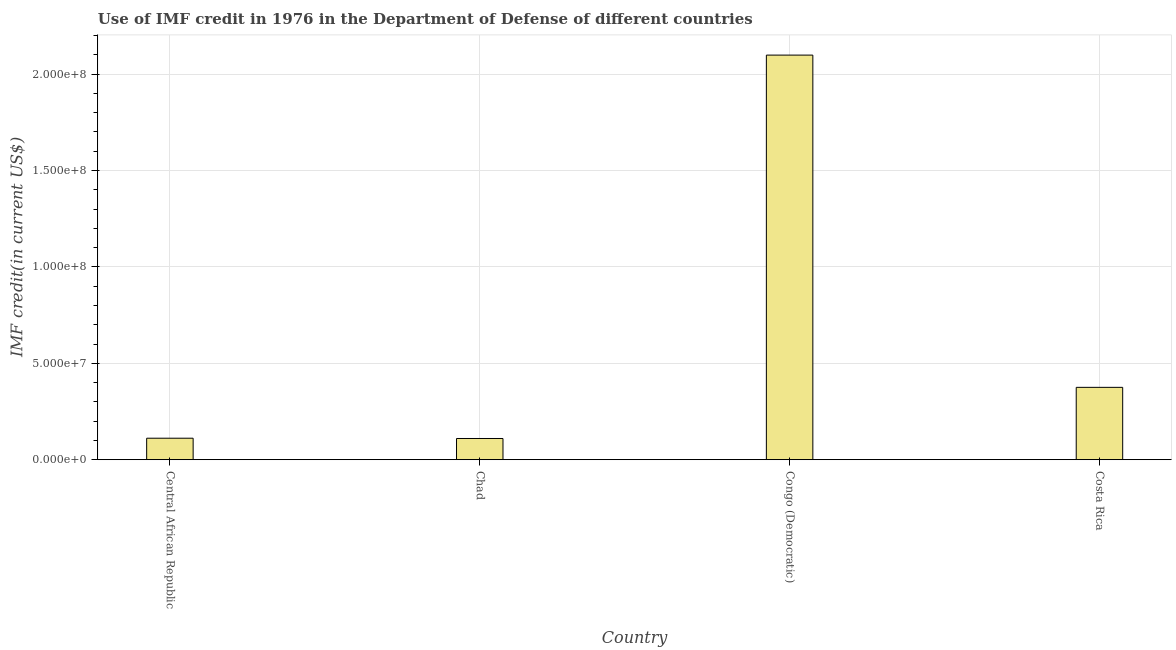Does the graph contain any zero values?
Offer a terse response. No. What is the title of the graph?
Your answer should be compact. Use of IMF credit in 1976 in the Department of Defense of different countries. What is the label or title of the Y-axis?
Offer a terse response. IMF credit(in current US$). What is the use of imf credit in dod in Central African Republic?
Make the answer very short. 1.11e+07. Across all countries, what is the maximum use of imf credit in dod?
Your response must be concise. 2.10e+08. Across all countries, what is the minimum use of imf credit in dod?
Offer a very short reply. 1.10e+07. In which country was the use of imf credit in dod maximum?
Offer a terse response. Congo (Democratic). In which country was the use of imf credit in dod minimum?
Provide a succinct answer. Chad. What is the sum of the use of imf credit in dod?
Offer a terse response. 2.70e+08. What is the difference between the use of imf credit in dod in Central African Republic and Congo (Democratic)?
Provide a succinct answer. -1.99e+08. What is the average use of imf credit in dod per country?
Give a very brief answer. 6.74e+07. What is the median use of imf credit in dod?
Your response must be concise. 2.43e+07. In how many countries, is the use of imf credit in dod greater than 50000000 US$?
Your answer should be very brief. 1. What is the ratio of the use of imf credit in dod in Central African Republic to that in Congo (Democratic)?
Offer a very short reply. 0.05. Is the use of imf credit in dod in Central African Republic less than that in Chad?
Provide a short and direct response. No. Is the difference between the use of imf credit in dod in Chad and Costa Rica greater than the difference between any two countries?
Make the answer very short. No. What is the difference between the highest and the second highest use of imf credit in dod?
Give a very brief answer. 1.72e+08. What is the difference between the highest and the lowest use of imf credit in dod?
Offer a very short reply. 1.99e+08. In how many countries, is the use of imf credit in dod greater than the average use of imf credit in dod taken over all countries?
Keep it short and to the point. 1. How many bars are there?
Keep it short and to the point. 4. How many countries are there in the graph?
Provide a succinct answer. 4. Are the values on the major ticks of Y-axis written in scientific E-notation?
Provide a short and direct response. Yes. What is the IMF credit(in current US$) in Central African Republic?
Give a very brief answer. 1.11e+07. What is the IMF credit(in current US$) of Chad?
Make the answer very short. 1.10e+07. What is the IMF credit(in current US$) of Congo (Democratic)?
Provide a succinct answer. 2.10e+08. What is the IMF credit(in current US$) of Costa Rica?
Offer a very short reply. 3.75e+07. What is the difference between the IMF credit(in current US$) in Central African Republic and Chad?
Give a very brief answer. 1.39e+05. What is the difference between the IMF credit(in current US$) in Central African Republic and Congo (Democratic)?
Your answer should be compact. -1.99e+08. What is the difference between the IMF credit(in current US$) in Central African Republic and Costa Rica?
Your answer should be very brief. -2.64e+07. What is the difference between the IMF credit(in current US$) in Chad and Congo (Democratic)?
Provide a succinct answer. -1.99e+08. What is the difference between the IMF credit(in current US$) in Chad and Costa Rica?
Keep it short and to the point. -2.65e+07. What is the difference between the IMF credit(in current US$) in Congo (Democratic) and Costa Rica?
Your response must be concise. 1.72e+08. What is the ratio of the IMF credit(in current US$) in Central African Republic to that in Chad?
Make the answer very short. 1.01. What is the ratio of the IMF credit(in current US$) in Central African Republic to that in Congo (Democratic)?
Make the answer very short. 0.05. What is the ratio of the IMF credit(in current US$) in Central African Republic to that in Costa Rica?
Give a very brief answer. 0.3. What is the ratio of the IMF credit(in current US$) in Chad to that in Congo (Democratic)?
Your answer should be compact. 0.05. What is the ratio of the IMF credit(in current US$) in Chad to that in Costa Rica?
Ensure brevity in your answer.  0.29. What is the ratio of the IMF credit(in current US$) in Congo (Democratic) to that in Costa Rica?
Offer a terse response. 5.59. 